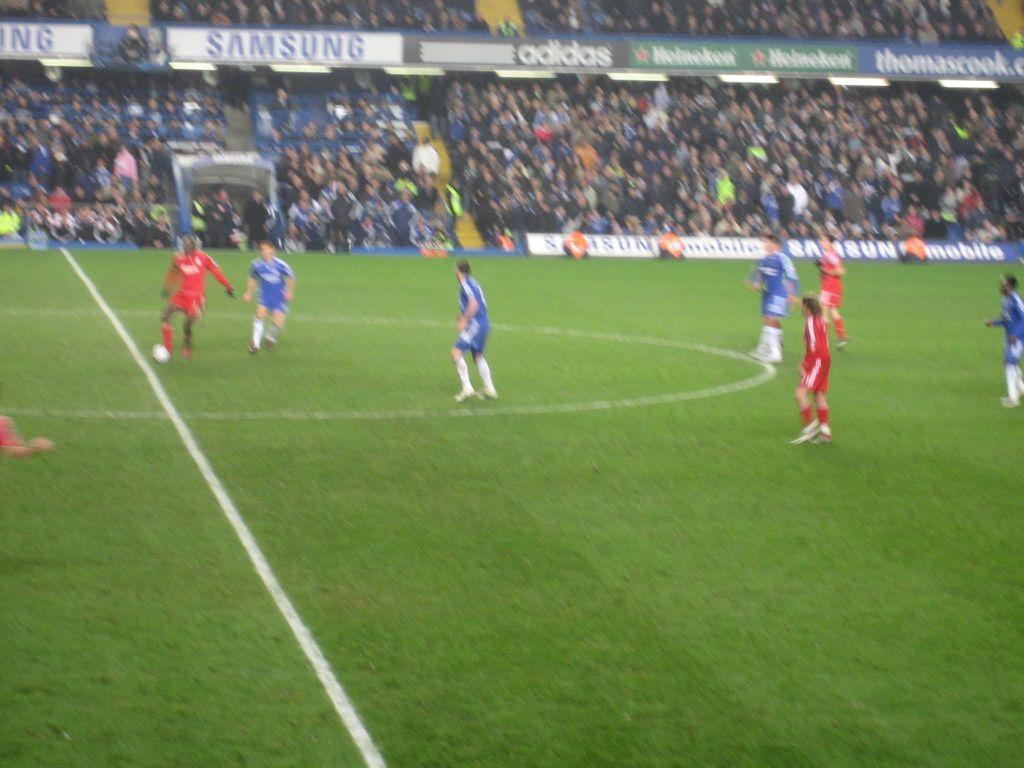<image>
Relay a brief, clear account of the picture shown. Soccer players near midfield at a stadium with advertisements by Samsung, Adidas and Heineken. 